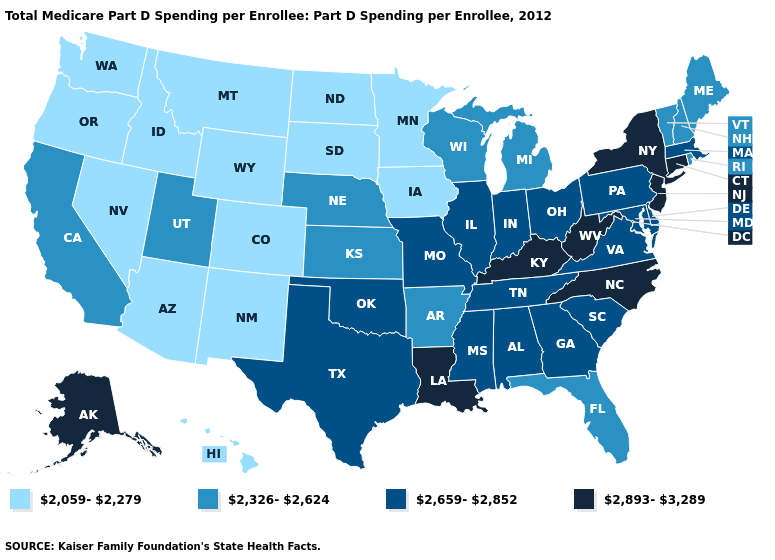Does Rhode Island have a higher value than North Dakota?
Short answer required. Yes. What is the highest value in the USA?
Be succinct. 2,893-3,289. Which states have the lowest value in the South?
Quick response, please. Arkansas, Florida. Among the states that border Maryland , does Pennsylvania have the highest value?
Be succinct. No. What is the value of Montana?
Answer briefly. 2,059-2,279. What is the highest value in states that border Virginia?
Concise answer only. 2,893-3,289. Does Louisiana have the same value as New Jersey?
Keep it brief. Yes. What is the highest value in states that border Ohio?
Concise answer only. 2,893-3,289. What is the value of Rhode Island?
Keep it brief. 2,326-2,624. Name the states that have a value in the range 2,059-2,279?
Give a very brief answer. Arizona, Colorado, Hawaii, Idaho, Iowa, Minnesota, Montana, Nevada, New Mexico, North Dakota, Oregon, South Dakota, Washington, Wyoming. What is the lowest value in the West?
Short answer required. 2,059-2,279. What is the lowest value in the USA?
Give a very brief answer. 2,059-2,279. Does New Jersey have the same value as Tennessee?
Answer briefly. No. What is the value of Florida?
Be succinct. 2,326-2,624. Name the states that have a value in the range 2,893-3,289?
Short answer required. Alaska, Connecticut, Kentucky, Louisiana, New Jersey, New York, North Carolina, West Virginia. 